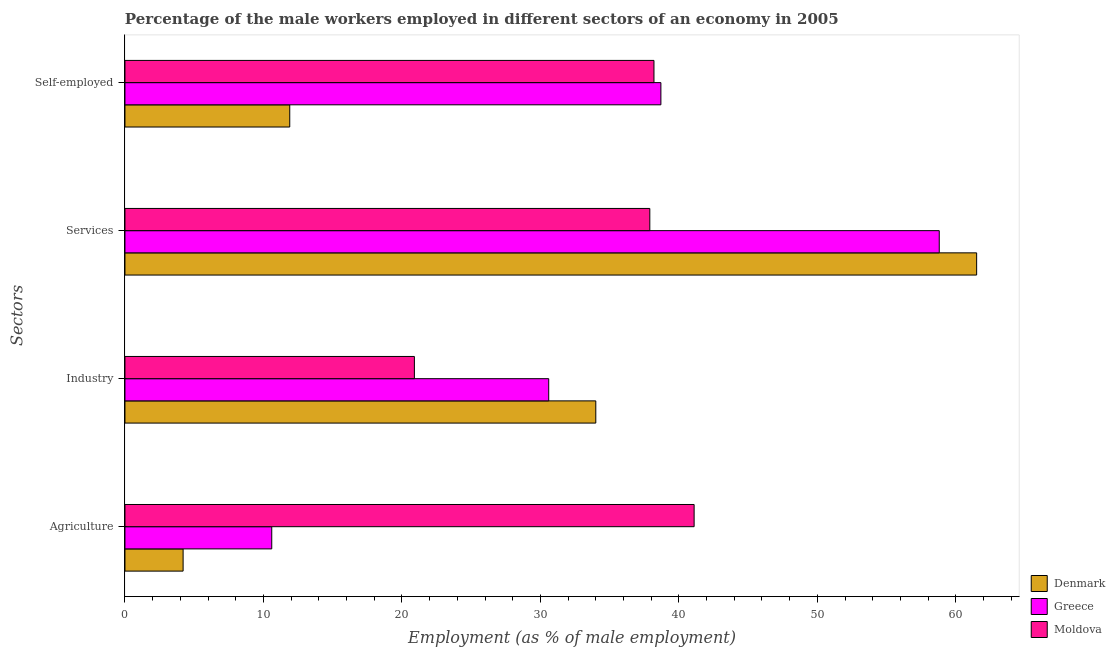Are the number of bars on each tick of the Y-axis equal?
Keep it short and to the point. Yes. What is the label of the 2nd group of bars from the top?
Your answer should be very brief. Services. What is the percentage of male workers in services in Moldova?
Provide a short and direct response. 37.9. Across all countries, what is the maximum percentage of male workers in agriculture?
Provide a succinct answer. 41.1. Across all countries, what is the minimum percentage of male workers in agriculture?
Provide a short and direct response. 4.2. In which country was the percentage of self employed male workers maximum?
Offer a terse response. Greece. In which country was the percentage of male workers in services minimum?
Provide a short and direct response. Moldova. What is the total percentage of male workers in agriculture in the graph?
Your answer should be very brief. 55.9. What is the difference between the percentage of male workers in agriculture in Moldova and that in Greece?
Make the answer very short. 30.5. What is the difference between the percentage of male workers in agriculture in Denmark and the percentage of male workers in services in Moldova?
Offer a very short reply. -33.7. What is the average percentage of male workers in agriculture per country?
Give a very brief answer. 18.63. What is the difference between the percentage of male workers in industry and percentage of male workers in agriculture in Denmark?
Make the answer very short. 29.8. In how many countries, is the percentage of male workers in industry greater than 10 %?
Offer a very short reply. 3. What is the ratio of the percentage of male workers in industry in Moldova to that in Denmark?
Your response must be concise. 0.61. Is the percentage of male workers in services in Greece less than that in Denmark?
Your answer should be compact. Yes. Is the difference between the percentage of male workers in services in Denmark and Moldova greater than the difference between the percentage of self employed male workers in Denmark and Moldova?
Your answer should be compact. Yes. What is the difference between the highest and the second highest percentage of male workers in industry?
Make the answer very short. 3.4. What is the difference between the highest and the lowest percentage of male workers in industry?
Your response must be concise. 13.1. In how many countries, is the percentage of self employed male workers greater than the average percentage of self employed male workers taken over all countries?
Make the answer very short. 2. Is the sum of the percentage of self employed male workers in Denmark and Moldova greater than the maximum percentage of male workers in agriculture across all countries?
Provide a succinct answer. Yes. Is it the case that in every country, the sum of the percentage of self employed male workers and percentage of male workers in industry is greater than the sum of percentage of male workers in services and percentage of male workers in agriculture?
Provide a short and direct response. No. What does the 2nd bar from the top in Industry represents?
Offer a very short reply. Greece. What does the 2nd bar from the bottom in Self-employed represents?
Your response must be concise. Greece. Is it the case that in every country, the sum of the percentage of male workers in agriculture and percentage of male workers in industry is greater than the percentage of male workers in services?
Provide a short and direct response. No. How many bars are there?
Provide a succinct answer. 12. Are all the bars in the graph horizontal?
Provide a short and direct response. Yes. How many countries are there in the graph?
Make the answer very short. 3. Are the values on the major ticks of X-axis written in scientific E-notation?
Make the answer very short. No. Where does the legend appear in the graph?
Your answer should be compact. Bottom right. How are the legend labels stacked?
Keep it short and to the point. Vertical. What is the title of the graph?
Ensure brevity in your answer.  Percentage of the male workers employed in different sectors of an economy in 2005. What is the label or title of the X-axis?
Your answer should be very brief. Employment (as % of male employment). What is the label or title of the Y-axis?
Provide a succinct answer. Sectors. What is the Employment (as % of male employment) in Denmark in Agriculture?
Keep it short and to the point. 4.2. What is the Employment (as % of male employment) in Greece in Agriculture?
Your response must be concise. 10.6. What is the Employment (as % of male employment) in Moldova in Agriculture?
Your answer should be compact. 41.1. What is the Employment (as % of male employment) in Greece in Industry?
Make the answer very short. 30.6. What is the Employment (as % of male employment) in Moldova in Industry?
Provide a short and direct response. 20.9. What is the Employment (as % of male employment) of Denmark in Services?
Your answer should be very brief. 61.5. What is the Employment (as % of male employment) in Greece in Services?
Your answer should be very brief. 58.8. What is the Employment (as % of male employment) in Moldova in Services?
Your response must be concise. 37.9. What is the Employment (as % of male employment) in Denmark in Self-employed?
Provide a succinct answer. 11.9. What is the Employment (as % of male employment) of Greece in Self-employed?
Offer a terse response. 38.7. What is the Employment (as % of male employment) in Moldova in Self-employed?
Provide a short and direct response. 38.2. Across all Sectors, what is the maximum Employment (as % of male employment) of Denmark?
Ensure brevity in your answer.  61.5. Across all Sectors, what is the maximum Employment (as % of male employment) of Greece?
Offer a terse response. 58.8. Across all Sectors, what is the maximum Employment (as % of male employment) in Moldova?
Your response must be concise. 41.1. Across all Sectors, what is the minimum Employment (as % of male employment) in Denmark?
Provide a short and direct response. 4.2. Across all Sectors, what is the minimum Employment (as % of male employment) of Greece?
Offer a very short reply. 10.6. Across all Sectors, what is the minimum Employment (as % of male employment) in Moldova?
Your answer should be very brief. 20.9. What is the total Employment (as % of male employment) of Denmark in the graph?
Ensure brevity in your answer.  111.6. What is the total Employment (as % of male employment) of Greece in the graph?
Offer a very short reply. 138.7. What is the total Employment (as % of male employment) of Moldova in the graph?
Your answer should be very brief. 138.1. What is the difference between the Employment (as % of male employment) of Denmark in Agriculture and that in Industry?
Make the answer very short. -29.8. What is the difference between the Employment (as % of male employment) of Moldova in Agriculture and that in Industry?
Provide a succinct answer. 20.2. What is the difference between the Employment (as % of male employment) of Denmark in Agriculture and that in Services?
Offer a terse response. -57.3. What is the difference between the Employment (as % of male employment) in Greece in Agriculture and that in Services?
Your answer should be very brief. -48.2. What is the difference between the Employment (as % of male employment) in Moldova in Agriculture and that in Services?
Keep it short and to the point. 3.2. What is the difference between the Employment (as % of male employment) in Denmark in Agriculture and that in Self-employed?
Make the answer very short. -7.7. What is the difference between the Employment (as % of male employment) of Greece in Agriculture and that in Self-employed?
Make the answer very short. -28.1. What is the difference between the Employment (as % of male employment) of Denmark in Industry and that in Services?
Ensure brevity in your answer.  -27.5. What is the difference between the Employment (as % of male employment) in Greece in Industry and that in Services?
Offer a terse response. -28.2. What is the difference between the Employment (as % of male employment) of Denmark in Industry and that in Self-employed?
Make the answer very short. 22.1. What is the difference between the Employment (as % of male employment) of Moldova in Industry and that in Self-employed?
Provide a short and direct response. -17.3. What is the difference between the Employment (as % of male employment) of Denmark in Services and that in Self-employed?
Provide a succinct answer. 49.6. What is the difference between the Employment (as % of male employment) in Greece in Services and that in Self-employed?
Keep it short and to the point. 20.1. What is the difference between the Employment (as % of male employment) of Moldova in Services and that in Self-employed?
Make the answer very short. -0.3. What is the difference between the Employment (as % of male employment) in Denmark in Agriculture and the Employment (as % of male employment) in Greece in Industry?
Your response must be concise. -26.4. What is the difference between the Employment (as % of male employment) in Denmark in Agriculture and the Employment (as % of male employment) in Moldova in Industry?
Offer a terse response. -16.7. What is the difference between the Employment (as % of male employment) of Denmark in Agriculture and the Employment (as % of male employment) of Greece in Services?
Your response must be concise. -54.6. What is the difference between the Employment (as % of male employment) of Denmark in Agriculture and the Employment (as % of male employment) of Moldova in Services?
Offer a terse response. -33.7. What is the difference between the Employment (as % of male employment) of Greece in Agriculture and the Employment (as % of male employment) of Moldova in Services?
Offer a terse response. -27.3. What is the difference between the Employment (as % of male employment) in Denmark in Agriculture and the Employment (as % of male employment) in Greece in Self-employed?
Provide a succinct answer. -34.5. What is the difference between the Employment (as % of male employment) of Denmark in Agriculture and the Employment (as % of male employment) of Moldova in Self-employed?
Offer a very short reply. -34. What is the difference between the Employment (as % of male employment) of Greece in Agriculture and the Employment (as % of male employment) of Moldova in Self-employed?
Make the answer very short. -27.6. What is the difference between the Employment (as % of male employment) of Denmark in Industry and the Employment (as % of male employment) of Greece in Services?
Your response must be concise. -24.8. What is the difference between the Employment (as % of male employment) in Denmark in Industry and the Employment (as % of male employment) in Moldova in Services?
Your answer should be very brief. -3.9. What is the difference between the Employment (as % of male employment) of Greece in Industry and the Employment (as % of male employment) of Moldova in Self-employed?
Offer a very short reply. -7.6. What is the difference between the Employment (as % of male employment) in Denmark in Services and the Employment (as % of male employment) in Greece in Self-employed?
Give a very brief answer. 22.8. What is the difference between the Employment (as % of male employment) of Denmark in Services and the Employment (as % of male employment) of Moldova in Self-employed?
Keep it short and to the point. 23.3. What is the difference between the Employment (as % of male employment) in Greece in Services and the Employment (as % of male employment) in Moldova in Self-employed?
Your response must be concise. 20.6. What is the average Employment (as % of male employment) of Denmark per Sectors?
Your answer should be very brief. 27.9. What is the average Employment (as % of male employment) of Greece per Sectors?
Give a very brief answer. 34.67. What is the average Employment (as % of male employment) of Moldova per Sectors?
Offer a terse response. 34.52. What is the difference between the Employment (as % of male employment) of Denmark and Employment (as % of male employment) of Moldova in Agriculture?
Keep it short and to the point. -36.9. What is the difference between the Employment (as % of male employment) in Greece and Employment (as % of male employment) in Moldova in Agriculture?
Your response must be concise. -30.5. What is the difference between the Employment (as % of male employment) of Denmark and Employment (as % of male employment) of Greece in Industry?
Keep it short and to the point. 3.4. What is the difference between the Employment (as % of male employment) of Denmark and Employment (as % of male employment) of Moldova in Industry?
Offer a very short reply. 13.1. What is the difference between the Employment (as % of male employment) of Denmark and Employment (as % of male employment) of Greece in Services?
Give a very brief answer. 2.7. What is the difference between the Employment (as % of male employment) in Denmark and Employment (as % of male employment) in Moldova in Services?
Your answer should be very brief. 23.6. What is the difference between the Employment (as % of male employment) in Greece and Employment (as % of male employment) in Moldova in Services?
Ensure brevity in your answer.  20.9. What is the difference between the Employment (as % of male employment) of Denmark and Employment (as % of male employment) of Greece in Self-employed?
Your response must be concise. -26.8. What is the difference between the Employment (as % of male employment) in Denmark and Employment (as % of male employment) in Moldova in Self-employed?
Provide a short and direct response. -26.3. What is the ratio of the Employment (as % of male employment) in Denmark in Agriculture to that in Industry?
Offer a terse response. 0.12. What is the ratio of the Employment (as % of male employment) in Greece in Agriculture to that in Industry?
Offer a terse response. 0.35. What is the ratio of the Employment (as % of male employment) of Moldova in Agriculture to that in Industry?
Provide a short and direct response. 1.97. What is the ratio of the Employment (as % of male employment) of Denmark in Agriculture to that in Services?
Offer a terse response. 0.07. What is the ratio of the Employment (as % of male employment) of Greece in Agriculture to that in Services?
Your response must be concise. 0.18. What is the ratio of the Employment (as % of male employment) in Moldova in Agriculture to that in Services?
Ensure brevity in your answer.  1.08. What is the ratio of the Employment (as % of male employment) of Denmark in Agriculture to that in Self-employed?
Make the answer very short. 0.35. What is the ratio of the Employment (as % of male employment) in Greece in Agriculture to that in Self-employed?
Your answer should be very brief. 0.27. What is the ratio of the Employment (as % of male employment) of Moldova in Agriculture to that in Self-employed?
Your response must be concise. 1.08. What is the ratio of the Employment (as % of male employment) of Denmark in Industry to that in Services?
Make the answer very short. 0.55. What is the ratio of the Employment (as % of male employment) in Greece in Industry to that in Services?
Offer a very short reply. 0.52. What is the ratio of the Employment (as % of male employment) of Moldova in Industry to that in Services?
Your response must be concise. 0.55. What is the ratio of the Employment (as % of male employment) of Denmark in Industry to that in Self-employed?
Make the answer very short. 2.86. What is the ratio of the Employment (as % of male employment) in Greece in Industry to that in Self-employed?
Your answer should be compact. 0.79. What is the ratio of the Employment (as % of male employment) in Moldova in Industry to that in Self-employed?
Offer a terse response. 0.55. What is the ratio of the Employment (as % of male employment) in Denmark in Services to that in Self-employed?
Your answer should be compact. 5.17. What is the ratio of the Employment (as % of male employment) of Greece in Services to that in Self-employed?
Your response must be concise. 1.52. What is the ratio of the Employment (as % of male employment) in Moldova in Services to that in Self-employed?
Your answer should be compact. 0.99. What is the difference between the highest and the second highest Employment (as % of male employment) of Greece?
Keep it short and to the point. 20.1. What is the difference between the highest and the lowest Employment (as % of male employment) of Denmark?
Your answer should be very brief. 57.3. What is the difference between the highest and the lowest Employment (as % of male employment) of Greece?
Ensure brevity in your answer.  48.2. What is the difference between the highest and the lowest Employment (as % of male employment) of Moldova?
Give a very brief answer. 20.2. 